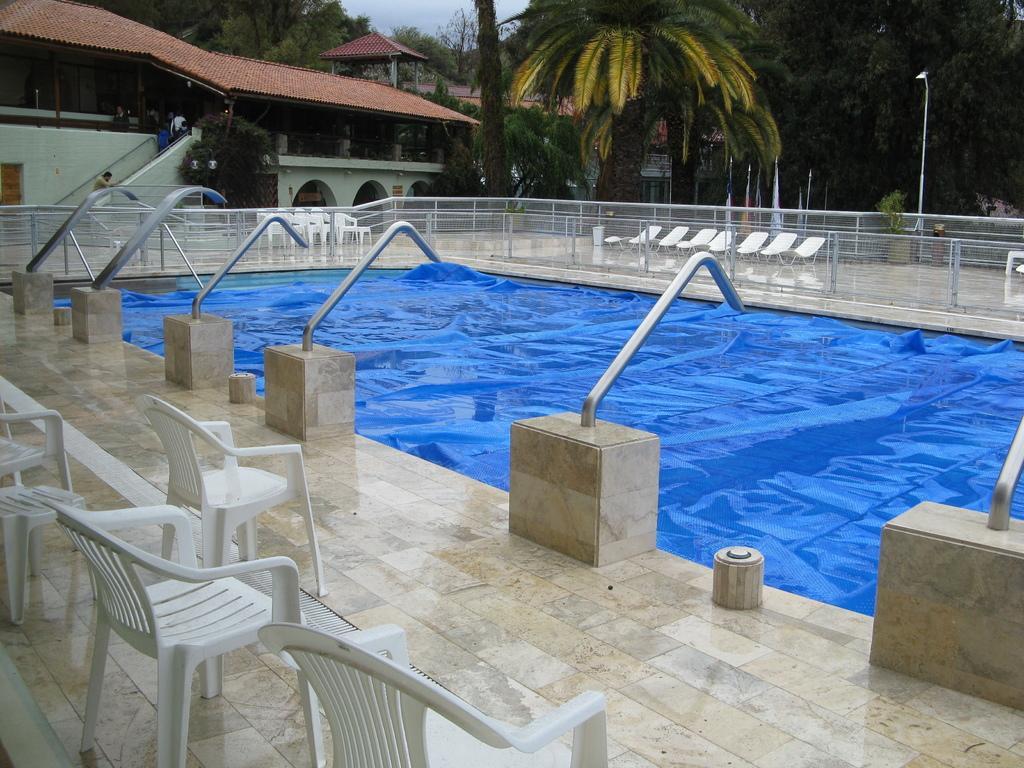In one or two sentences, can you explain what this image depicts? There are white color chairs arranged on the floor of a swimming pool, which is having blue color water in it. There are poles on the floor and there is fencing on the floor. In the background, there are buildings which are having roofs, there are trees and there is a sky. 